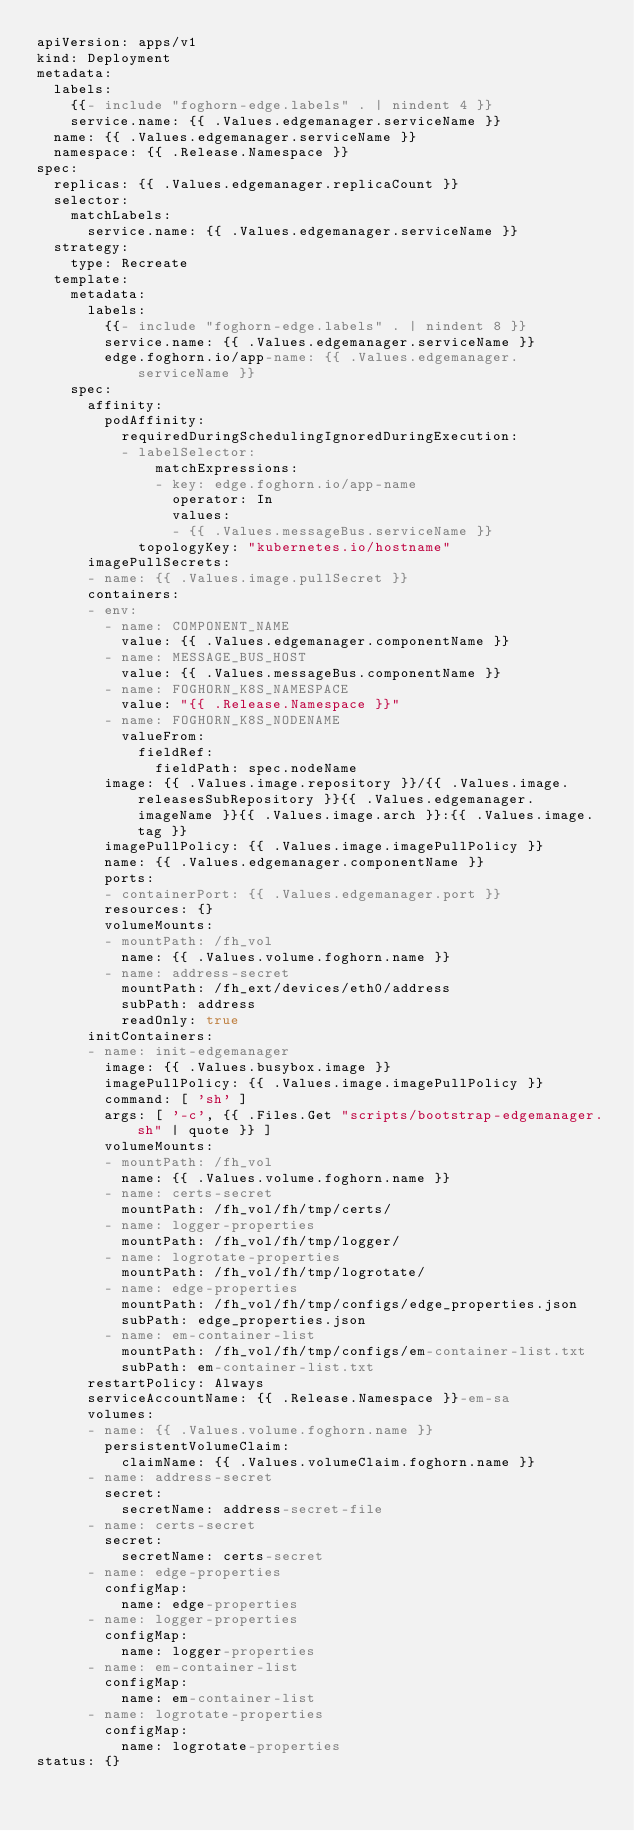Convert code to text. <code><loc_0><loc_0><loc_500><loc_500><_YAML_>apiVersion: apps/v1
kind: Deployment
metadata:
  labels:
    {{- include "foghorn-edge.labels" . | nindent 4 }}
    service.name: {{ .Values.edgemanager.serviceName }}
  name: {{ .Values.edgemanager.serviceName }}
  namespace: {{ .Release.Namespace }}
spec:
  replicas: {{ .Values.edgemanager.replicaCount }}
  selector:
    matchLabels:
      service.name: {{ .Values.edgemanager.serviceName }}
  strategy:
    type: Recreate
  template:
    metadata:
      labels:
        {{- include "foghorn-edge.labels" . | nindent 8 }}
        service.name: {{ .Values.edgemanager.serviceName }}
        edge.foghorn.io/app-name: {{ .Values.edgemanager.serviceName }}
    spec:
      affinity:
        podAffinity:
          requiredDuringSchedulingIgnoredDuringExecution:
          - labelSelector:
              matchExpressions:
              - key: edge.foghorn.io/app-name
                operator: In
                values:
                - {{ .Values.messageBus.serviceName }}
            topologyKey: "kubernetes.io/hostname"
      imagePullSecrets:
      - name: {{ .Values.image.pullSecret }}
      containers:
      - env:
        - name: COMPONENT_NAME
          value: {{ .Values.edgemanager.componentName }}
        - name: MESSAGE_BUS_HOST
          value: {{ .Values.messageBus.componentName }}
        - name: FOGHORN_K8S_NAMESPACE
          value: "{{ .Release.Namespace }}"
        - name: FOGHORN_K8S_NODENAME
          valueFrom:
            fieldRef:
              fieldPath: spec.nodeName
        image: {{ .Values.image.repository }}/{{ .Values.image.releasesSubRepository }}{{ .Values.edgemanager.imageName }}{{ .Values.image.arch }}:{{ .Values.image.tag }}
        imagePullPolicy: {{ .Values.image.imagePullPolicy }}
        name: {{ .Values.edgemanager.componentName }}
        ports:
        - containerPort: {{ .Values.edgemanager.port }}
        resources: {}
        volumeMounts:
        - mountPath: /fh_vol
          name: {{ .Values.volume.foghorn.name }}
        - name: address-secret
          mountPath: /fh_ext/devices/eth0/address
          subPath: address
          readOnly: true
      initContainers:
      - name: init-edgemanager
        image: {{ .Values.busybox.image }}
        imagePullPolicy: {{ .Values.image.imagePullPolicy }}
        command: [ 'sh' ]
        args: [ '-c', {{ .Files.Get "scripts/bootstrap-edgemanager.sh" | quote }} ]
        volumeMounts:
        - mountPath: /fh_vol
          name: {{ .Values.volume.foghorn.name }}
        - name: certs-secret
          mountPath: /fh_vol/fh/tmp/certs/
        - name: logger-properties
          mountPath: /fh_vol/fh/tmp/logger/
        - name: logrotate-properties
          mountPath: /fh_vol/fh/tmp/logrotate/
        - name: edge-properties
          mountPath: /fh_vol/fh/tmp/configs/edge_properties.json
          subPath: edge_properties.json
        - name: em-container-list
          mountPath: /fh_vol/fh/tmp/configs/em-container-list.txt
          subPath: em-container-list.txt
      restartPolicy: Always
      serviceAccountName: {{ .Release.Namespace }}-em-sa
      volumes:
      - name: {{ .Values.volume.foghorn.name }}
        persistentVolumeClaim:
          claimName: {{ .Values.volumeClaim.foghorn.name }}
      - name: address-secret
        secret:
          secretName: address-secret-file
      - name: certs-secret
        secret:
          secretName: certs-secret
      - name: edge-properties
        configMap:
          name: edge-properties
      - name: logger-properties
        configMap:
          name: logger-properties
      - name: em-container-list
        configMap:
          name: em-container-list
      - name: logrotate-properties
        configMap:
          name: logrotate-properties
status: {}
</code> 